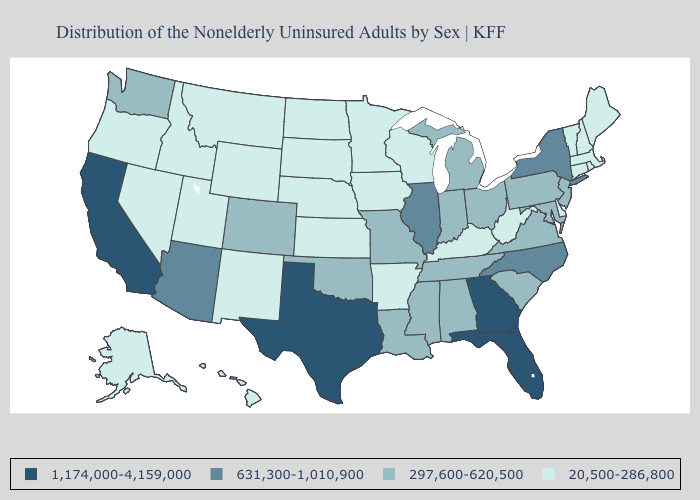Among the states that border Kansas , which have the highest value?
Short answer required. Colorado, Missouri, Oklahoma. Does Ohio have the same value as Virginia?
Give a very brief answer. Yes. Does South Dakota have the highest value in the MidWest?
Keep it brief. No. Does Missouri have the lowest value in the MidWest?
Write a very short answer. No. Among the states that border Alabama , which have the highest value?
Keep it brief. Florida, Georgia. How many symbols are there in the legend?
Keep it brief. 4. How many symbols are there in the legend?
Short answer required. 4. Name the states that have a value in the range 297,600-620,500?
Write a very short answer. Alabama, Colorado, Indiana, Louisiana, Maryland, Michigan, Mississippi, Missouri, New Jersey, Ohio, Oklahoma, Pennsylvania, South Carolina, Tennessee, Virginia, Washington. Name the states that have a value in the range 297,600-620,500?
Be succinct. Alabama, Colorado, Indiana, Louisiana, Maryland, Michigan, Mississippi, Missouri, New Jersey, Ohio, Oklahoma, Pennsylvania, South Carolina, Tennessee, Virginia, Washington. Name the states that have a value in the range 297,600-620,500?
Give a very brief answer. Alabama, Colorado, Indiana, Louisiana, Maryland, Michigan, Mississippi, Missouri, New Jersey, Ohio, Oklahoma, Pennsylvania, South Carolina, Tennessee, Virginia, Washington. What is the lowest value in the Northeast?
Be succinct. 20,500-286,800. What is the value of New York?
Answer briefly. 631,300-1,010,900. Does Minnesota have the lowest value in the USA?
Give a very brief answer. Yes. What is the value of Vermont?
Write a very short answer. 20,500-286,800. 